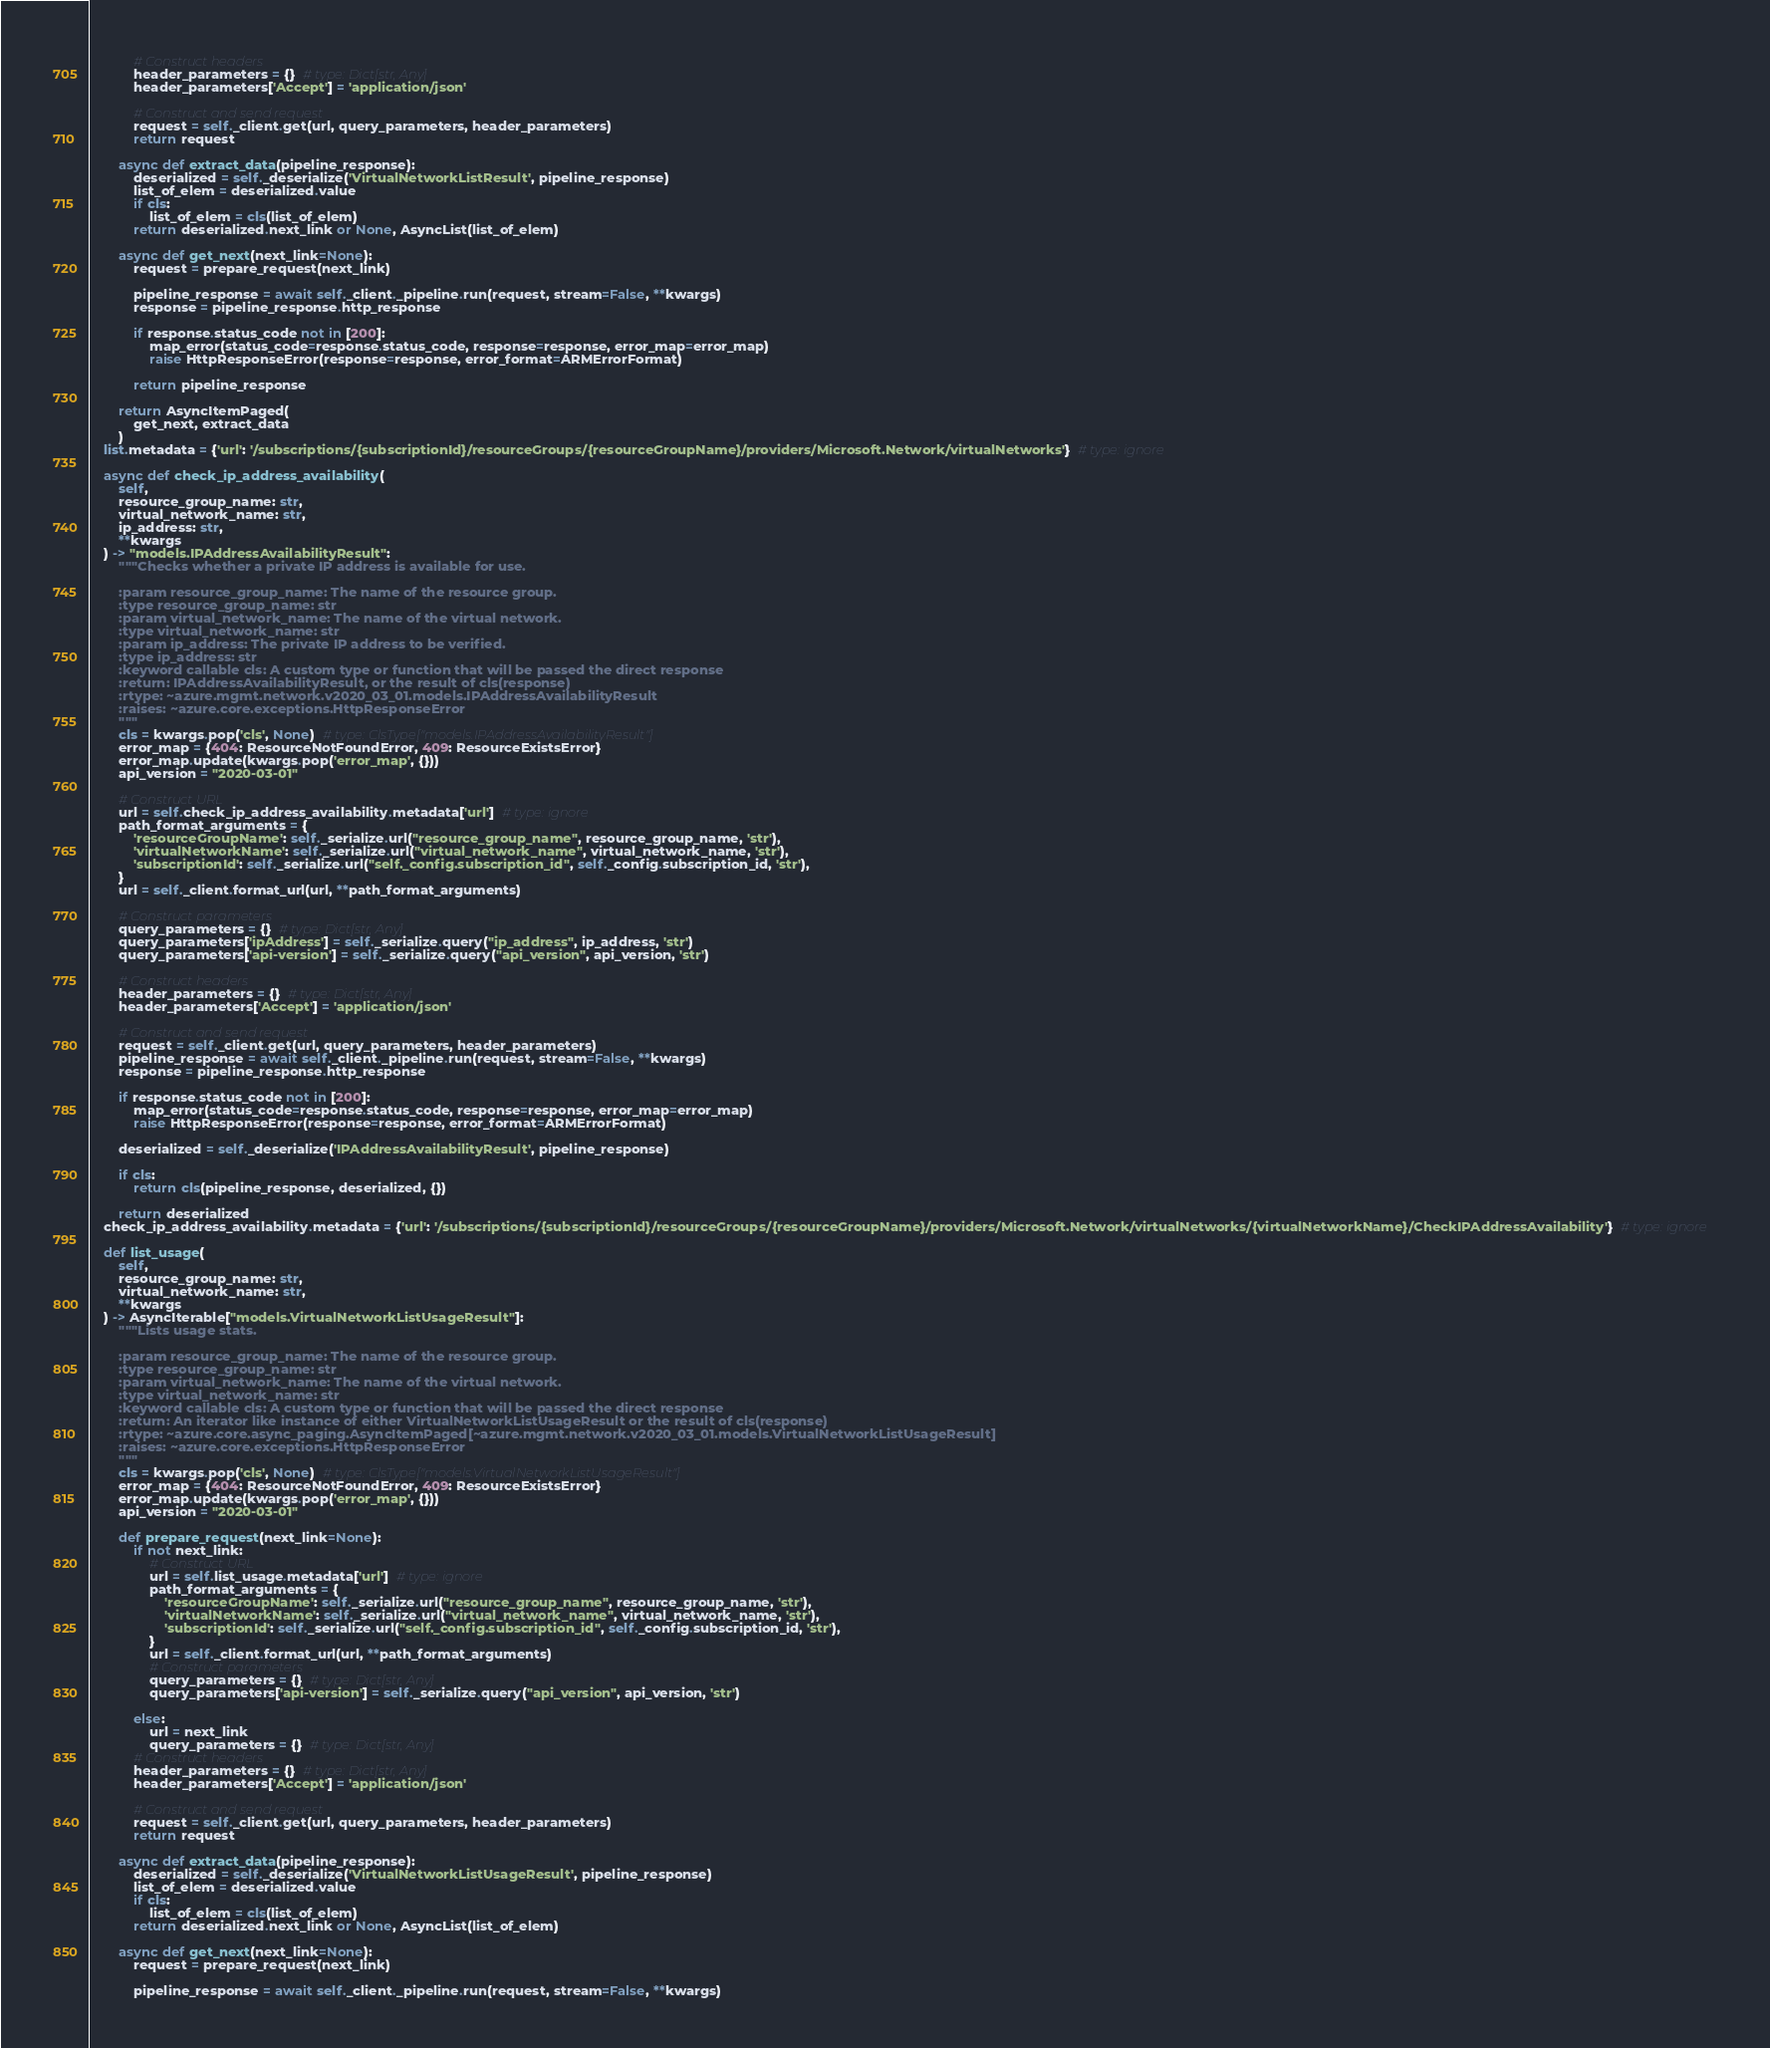Convert code to text. <code><loc_0><loc_0><loc_500><loc_500><_Python_>            # Construct headers
            header_parameters = {}  # type: Dict[str, Any]
            header_parameters['Accept'] = 'application/json'

            # Construct and send request
            request = self._client.get(url, query_parameters, header_parameters)
            return request

        async def extract_data(pipeline_response):
            deserialized = self._deserialize('VirtualNetworkListResult', pipeline_response)
            list_of_elem = deserialized.value
            if cls:
                list_of_elem = cls(list_of_elem)
            return deserialized.next_link or None, AsyncList(list_of_elem)

        async def get_next(next_link=None):
            request = prepare_request(next_link)

            pipeline_response = await self._client._pipeline.run(request, stream=False, **kwargs)
            response = pipeline_response.http_response

            if response.status_code not in [200]:
                map_error(status_code=response.status_code, response=response, error_map=error_map)
                raise HttpResponseError(response=response, error_format=ARMErrorFormat)

            return pipeline_response

        return AsyncItemPaged(
            get_next, extract_data
        )
    list.metadata = {'url': '/subscriptions/{subscriptionId}/resourceGroups/{resourceGroupName}/providers/Microsoft.Network/virtualNetworks'}  # type: ignore

    async def check_ip_address_availability(
        self,
        resource_group_name: str,
        virtual_network_name: str,
        ip_address: str,
        **kwargs
    ) -> "models.IPAddressAvailabilityResult":
        """Checks whether a private IP address is available for use.

        :param resource_group_name: The name of the resource group.
        :type resource_group_name: str
        :param virtual_network_name: The name of the virtual network.
        :type virtual_network_name: str
        :param ip_address: The private IP address to be verified.
        :type ip_address: str
        :keyword callable cls: A custom type or function that will be passed the direct response
        :return: IPAddressAvailabilityResult, or the result of cls(response)
        :rtype: ~azure.mgmt.network.v2020_03_01.models.IPAddressAvailabilityResult
        :raises: ~azure.core.exceptions.HttpResponseError
        """
        cls = kwargs.pop('cls', None)  # type: ClsType["models.IPAddressAvailabilityResult"]
        error_map = {404: ResourceNotFoundError, 409: ResourceExistsError}
        error_map.update(kwargs.pop('error_map', {}))
        api_version = "2020-03-01"

        # Construct URL
        url = self.check_ip_address_availability.metadata['url']  # type: ignore
        path_format_arguments = {
            'resourceGroupName': self._serialize.url("resource_group_name", resource_group_name, 'str'),
            'virtualNetworkName': self._serialize.url("virtual_network_name", virtual_network_name, 'str'),
            'subscriptionId': self._serialize.url("self._config.subscription_id", self._config.subscription_id, 'str'),
        }
        url = self._client.format_url(url, **path_format_arguments)

        # Construct parameters
        query_parameters = {}  # type: Dict[str, Any]
        query_parameters['ipAddress'] = self._serialize.query("ip_address", ip_address, 'str')
        query_parameters['api-version'] = self._serialize.query("api_version", api_version, 'str')

        # Construct headers
        header_parameters = {}  # type: Dict[str, Any]
        header_parameters['Accept'] = 'application/json'

        # Construct and send request
        request = self._client.get(url, query_parameters, header_parameters)
        pipeline_response = await self._client._pipeline.run(request, stream=False, **kwargs)
        response = pipeline_response.http_response

        if response.status_code not in [200]:
            map_error(status_code=response.status_code, response=response, error_map=error_map)
            raise HttpResponseError(response=response, error_format=ARMErrorFormat)

        deserialized = self._deserialize('IPAddressAvailabilityResult', pipeline_response)

        if cls:
            return cls(pipeline_response, deserialized, {})

        return deserialized
    check_ip_address_availability.metadata = {'url': '/subscriptions/{subscriptionId}/resourceGroups/{resourceGroupName}/providers/Microsoft.Network/virtualNetworks/{virtualNetworkName}/CheckIPAddressAvailability'}  # type: ignore

    def list_usage(
        self,
        resource_group_name: str,
        virtual_network_name: str,
        **kwargs
    ) -> AsyncIterable["models.VirtualNetworkListUsageResult"]:
        """Lists usage stats.

        :param resource_group_name: The name of the resource group.
        :type resource_group_name: str
        :param virtual_network_name: The name of the virtual network.
        :type virtual_network_name: str
        :keyword callable cls: A custom type or function that will be passed the direct response
        :return: An iterator like instance of either VirtualNetworkListUsageResult or the result of cls(response)
        :rtype: ~azure.core.async_paging.AsyncItemPaged[~azure.mgmt.network.v2020_03_01.models.VirtualNetworkListUsageResult]
        :raises: ~azure.core.exceptions.HttpResponseError
        """
        cls = kwargs.pop('cls', None)  # type: ClsType["models.VirtualNetworkListUsageResult"]
        error_map = {404: ResourceNotFoundError, 409: ResourceExistsError}
        error_map.update(kwargs.pop('error_map', {}))
        api_version = "2020-03-01"

        def prepare_request(next_link=None):
            if not next_link:
                # Construct URL
                url = self.list_usage.metadata['url']  # type: ignore
                path_format_arguments = {
                    'resourceGroupName': self._serialize.url("resource_group_name", resource_group_name, 'str'),
                    'virtualNetworkName': self._serialize.url("virtual_network_name", virtual_network_name, 'str'),
                    'subscriptionId': self._serialize.url("self._config.subscription_id", self._config.subscription_id, 'str'),
                }
                url = self._client.format_url(url, **path_format_arguments)
                # Construct parameters
                query_parameters = {}  # type: Dict[str, Any]
                query_parameters['api-version'] = self._serialize.query("api_version", api_version, 'str')

            else:
                url = next_link
                query_parameters = {}  # type: Dict[str, Any]
            # Construct headers
            header_parameters = {}  # type: Dict[str, Any]
            header_parameters['Accept'] = 'application/json'

            # Construct and send request
            request = self._client.get(url, query_parameters, header_parameters)
            return request

        async def extract_data(pipeline_response):
            deserialized = self._deserialize('VirtualNetworkListUsageResult', pipeline_response)
            list_of_elem = deserialized.value
            if cls:
                list_of_elem = cls(list_of_elem)
            return deserialized.next_link or None, AsyncList(list_of_elem)

        async def get_next(next_link=None):
            request = prepare_request(next_link)

            pipeline_response = await self._client._pipeline.run(request, stream=False, **kwargs)</code> 